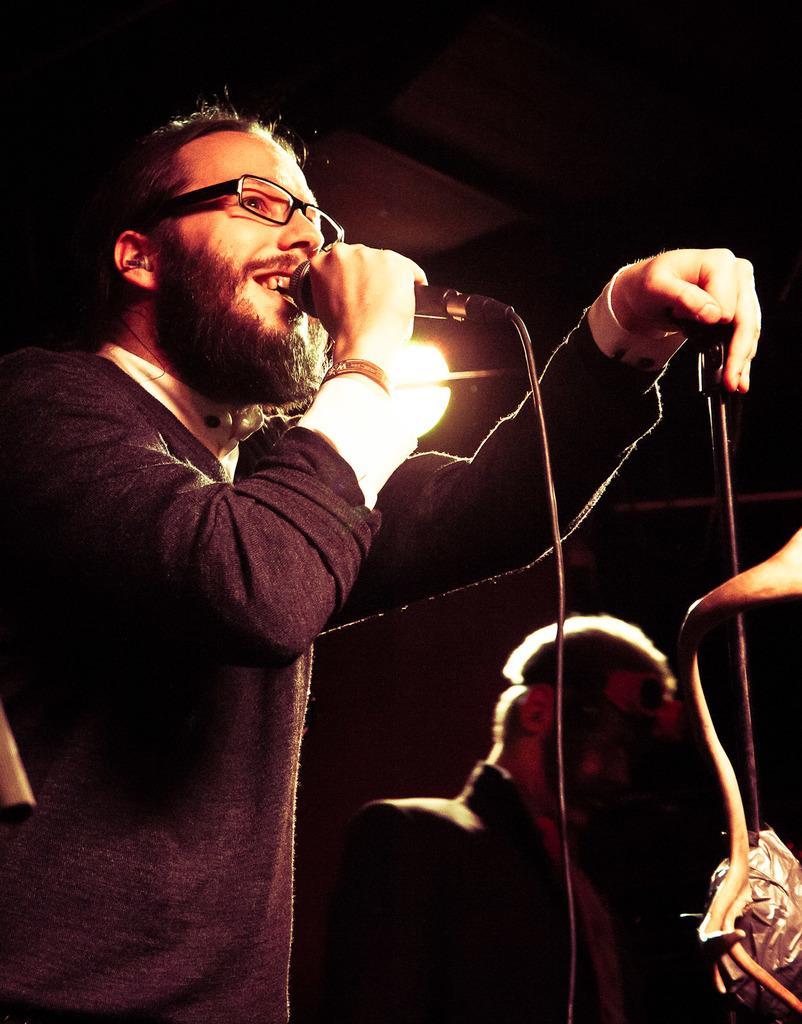Please provide a concise description of this image. In the image there is a man holding a mike in one hand and putting another hand on a stand. He is wearing a brown t shirt. In the right corner there is another man, he is wearing a blazer. 